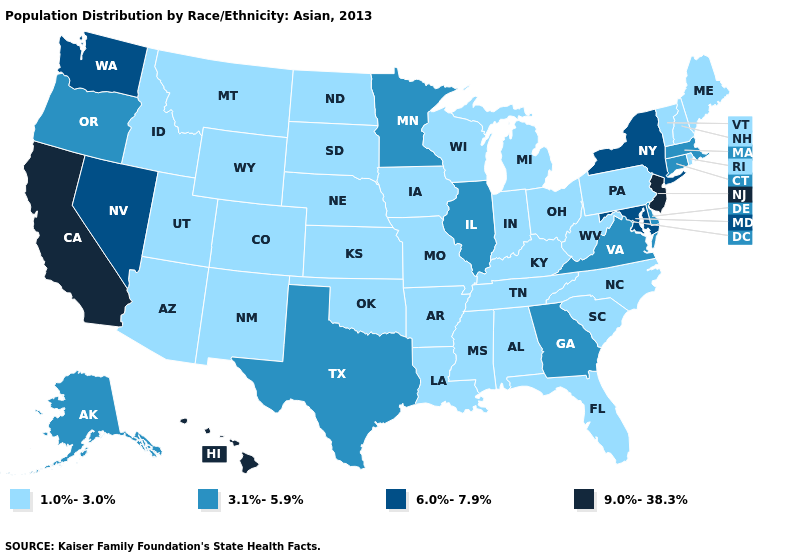What is the lowest value in the USA?
Quick response, please. 1.0%-3.0%. What is the value of Idaho?
Concise answer only. 1.0%-3.0%. Does Maryland have a lower value than Texas?
Be succinct. No. What is the value of Rhode Island?
Short answer required. 1.0%-3.0%. Is the legend a continuous bar?
Give a very brief answer. No. Which states have the lowest value in the West?
Write a very short answer. Arizona, Colorado, Idaho, Montana, New Mexico, Utah, Wyoming. What is the lowest value in states that border Arkansas?
Answer briefly. 1.0%-3.0%. What is the value of Oregon?
Write a very short answer. 3.1%-5.9%. What is the value of Indiana?
Answer briefly. 1.0%-3.0%. What is the value of South Dakota?
Be succinct. 1.0%-3.0%. Does the first symbol in the legend represent the smallest category?
Give a very brief answer. Yes. Does Massachusetts have the lowest value in the USA?
Write a very short answer. No. Which states have the lowest value in the USA?
Quick response, please. Alabama, Arizona, Arkansas, Colorado, Florida, Idaho, Indiana, Iowa, Kansas, Kentucky, Louisiana, Maine, Michigan, Mississippi, Missouri, Montana, Nebraska, New Hampshire, New Mexico, North Carolina, North Dakota, Ohio, Oklahoma, Pennsylvania, Rhode Island, South Carolina, South Dakota, Tennessee, Utah, Vermont, West Virginia, Wisconsin, Wyoming. Among the states that border Iowa , does Minnesota have the highest value?
Write a very short answer. Yes. Which states have the lowest value in the USA?
Short answer required. Alabama, Arizona, Arkansas, Colorado, Florida, Idaho, Indiana, Iowa, Kansas, Kentucky, Louisiana, Maine, Michigan, Mississippi, Missouri, Montana, Nebraska, New Hampshire, New Mexico, North Carolina, North Dakota, Ohio, Oklahoma, Pennsylvania, Rhode Island, South Carolina, South Dakota, Tennessee, Utah, Vermont, West Virginia, Wisconsin, Wyoming. 